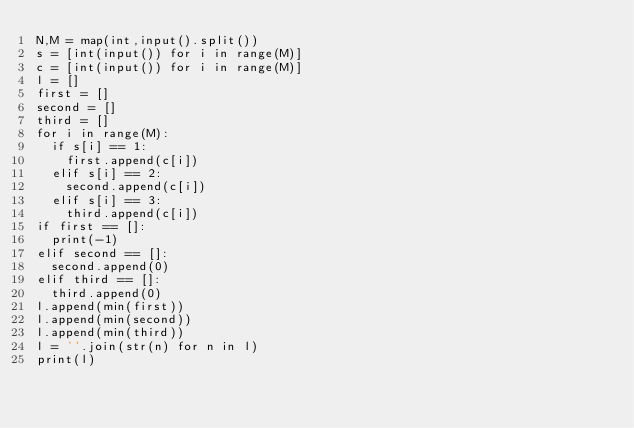<code> <loc_0><loc_0><loc_500><loc_500><_Python_>N,M = map(int,input().split())
s = [int(input()) for i in range(M)]
c = [int(input()) for i in range(M)]
l = []
first = []
second = []
third = []
for i in range(M):
  if s[i] == 1:
    first.append(c[i])
  elif s[i] == 2:
    second.append(c[i])
  elif s[i] == 3:
    third.append(c[i])
if first == []:
  print(-1)
elif second == []:
  second.append(0)
elif third == []:
  third.append(0)
l.append(min(first))
l.append(min(second))
l.append(min(third))
l = ''.join(str(n) for n in l)
print(l)

</code> 